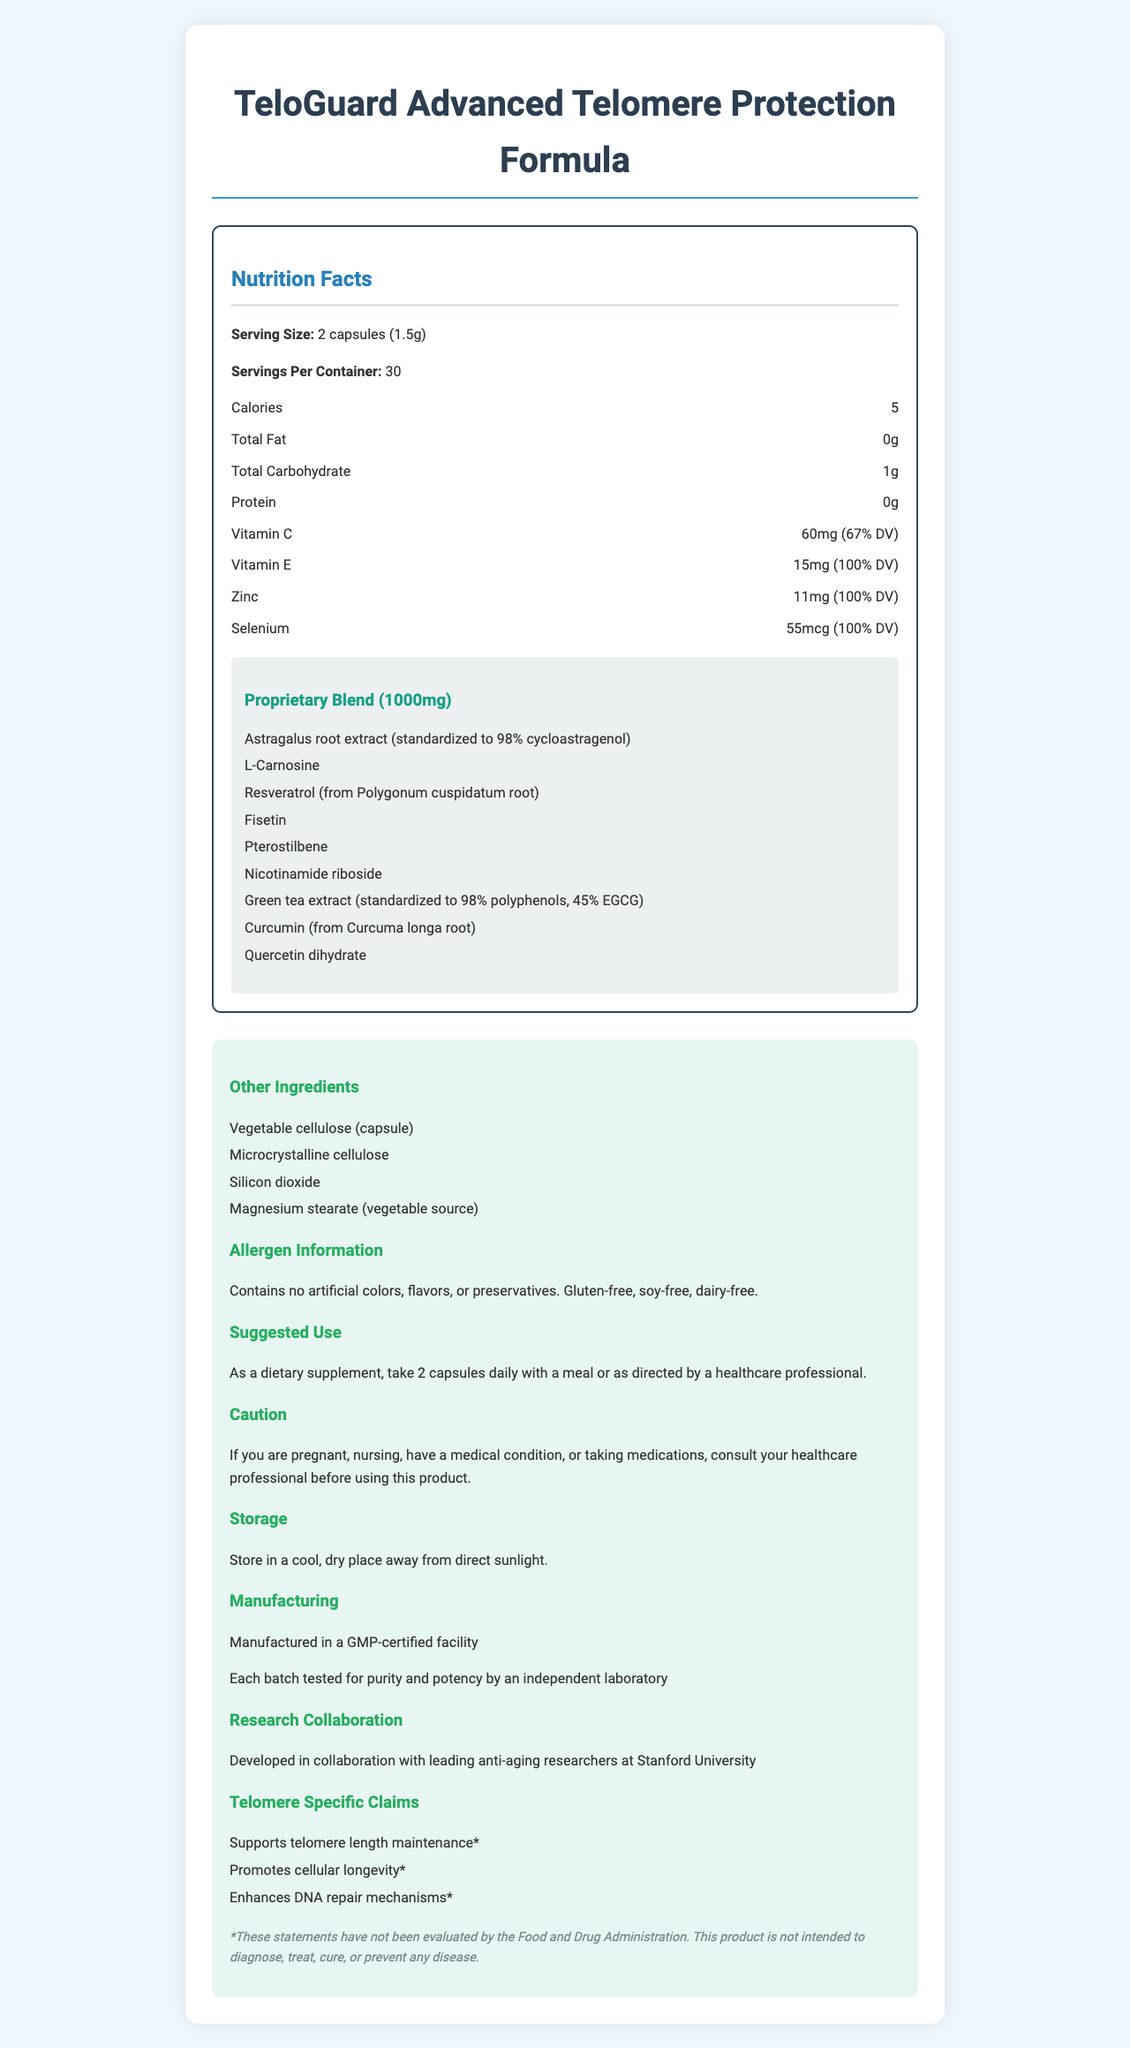what is the serving size? The serving size is mentioned at the beginning under the "Nutrition Facts" section as "Serving Size: 2 capsules (1.5g)."
Answer: 2 capsules (1.5g) how many servings are in one container? The number of servings per container is listed as 30 in the "Nutrition Facts" section.
Answer: 30 how many calories are in one serving? According to the "Nutrition Facts" section, one serving contains 5 calories.
Answer: 5 name two vitamins included in the formula and their daily values The document lists Vitamin C at 60mg (67% DV) and Vitamin E at 15mg (100% DV) in the "Nutrition Facts."
Answer: Vitamin C - 67% DV, Vitamin E - 100% DV which bioactive compounds are standardized to 98%? The proprietary blend lists Astragalus root extract standardized to 98% cycloastragenol and Green tea extract standardized to 98% polyphenols.
Answer: Astragalus root extract (cycloastragenol) and Green tea extract (polyphenols) what are the precautions mentioned for using this product? The "Caution" section mentions consulting a healthcare professional before use if pregnant, nursing, having a medical condition, or taking medications.
Answer: Consult your healthcare professional before using this product if you are pregnant, nursing, have a medical condition, or taking medications. does the product contain gluten? According to the allergen information, the product is gluten-free.
Answer: No which institution collaborated in developing this product? The "Research Collaboration" section notes the product was developed in collaboration with leading anti-aging researchers at Stanford University.
Answer: Stanford University what are the claimed benefits related to telomeres in the product? These benefits are listed under "Telomere Specific Claims" in the document.
Answer: Supports telomere length maintenance, Promotes cellular longevity, Enhances DNA repair mechanisms which ingredient is not part of the proprietary blend? A. Resveratrol B. Quercetin dihydrate C. Microcrystalline cellulose D. Fisetin Microcrystalline cellulose is listed under "Other Ingredients," not as part of the proprietary blend.
Answer: C. Microcrystalline cellulose how much vitamin E is in one serving? A. 10mg B. 15mg C. 20mg D. 25mg The "Nutrition Facts" section lists 15mg of Vitamin E per serving, which is 100% of the daily value.
Answer: B. 15mg does the product contain artificial colors, flavors, or preservatives? The allergen information specifies that the product contains no artificial colors, flavors, or preservatives.
Answer: No describe the main idea of the document The document briefly introduces the product, lists its nutritional content, detailed proprietary ingredients, usage guidelines, and the benefits related to telomere protection, emphasizing its development in collaboration with Stanford University and the lack of allergens.
Answer: This document provides the nutrition facts and detailed information about "TeloGuard Advanced Telomere Protection Formula", a dietary supplement aimed at telomere protection. It highlights the serving size, nutrients, proprietary blend ingredients, usage instructions, allergen information, and the research collaboration behind the product. Additionally, it outlines the product's benefits for telomere maintenance, cellular longevity, and DNA repair mechanisms. does this product contain soy? The allergen information clearly indicates that the product is soy-free.
Answer: No what is the level of L-Carnosine per serving? The document mentions L-Carnosine as part of the proprietary blend but doesn't specify its exact amount.
Answer: Not enough information 